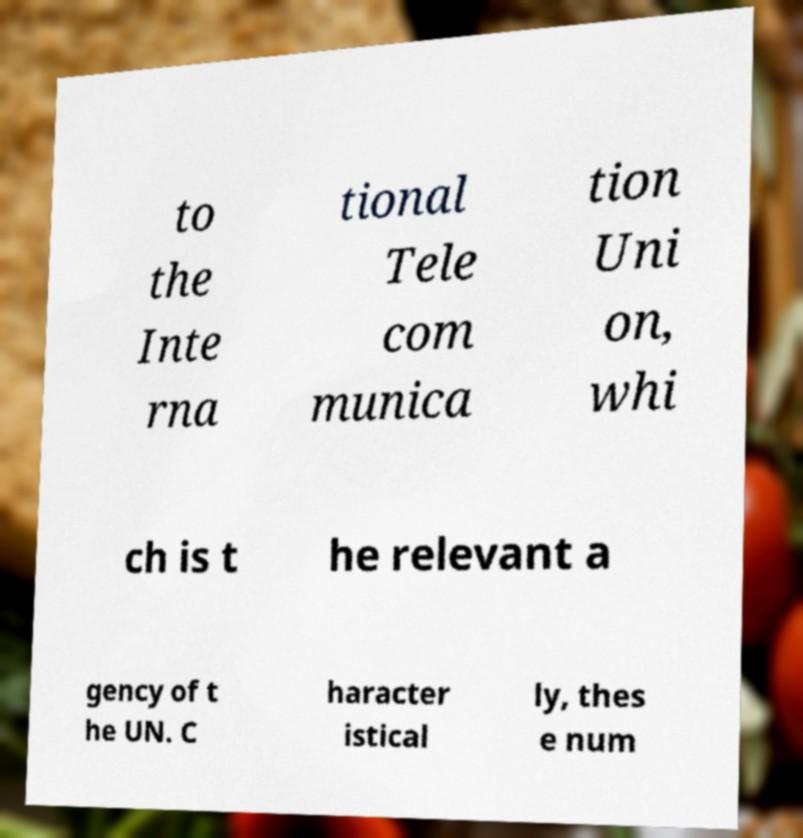Could you extract and type out the text from this image? to the Inte rna tional Tele com munica tion Uni on, whi ch is t he relevant a gency of t he UN. C haracter istical ly, thes e num 